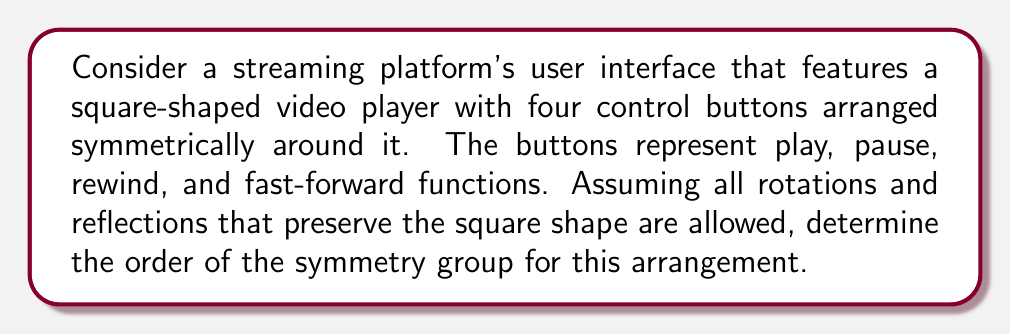Can you answer this question? To solve this problem, we need to analyze the symmetries of a square with four distinct elements (buttons) placed at each corner. Let's approach this step-by-step:

1) First, recall that the symmetry group of a square without distinct elements is the dihedral group $D_4$, which has order 8.

2) However, in this case, we have distinct buttons at each corner, which restricts the number of symmetries.

3) Let's enumerate the possible symmetries:
   a) Identity transformation (leaving everything as is)
   b) Rotation by 90° clockwise
   c) Rotation by 180°
   d) Rotation by 90° counterclockwise

4) Note that reflections are not allowed in this case because they would change the positions of the distinct buttons, creating a different arrangement.

5) We can verify that these four transformations form a group:
   - They are closed under composition
   - The identity element exists
   - Each element has an inverse
   - Composition is associative

6) This group is isomorphic to the cyclic group $C_4$.

7) Therefore, the order of the symmetry group is 4.

This symmetry group represents the ways the streaming platform can rotate its user interface while maintaining the functionality and relative positions of the control buttons.
Answer: The order of the symmetry group is 4. 